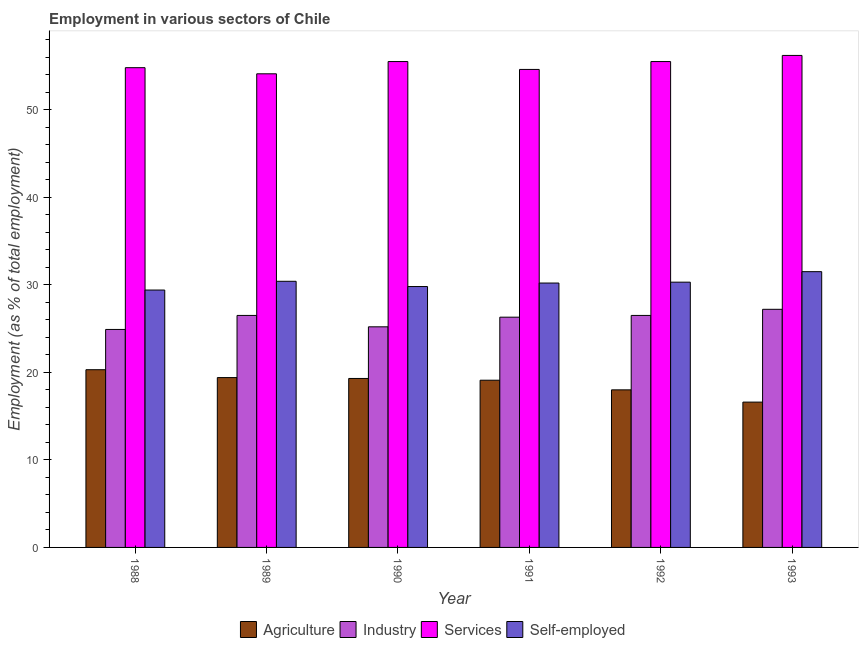How many different coloured bars are there?
Your answer should be very brief. 4. Are the number of bars per tick equal to the number of legend labels?
Your answer should be very brief. Yes. How many bars are there on the 5th tick from the left?
Your answer should be compact. 4. How many bars are there on the 6th tick from the right?
Give a very brief answer. 4. What is the label of the 5th group of bars from the left?
Make the answer very short. 1992. What is the percentage of workers in industry in 1991?
Ensure brevity in your answer.  26.3. Across all years, what is the maximum percentage of workers in industry?
Provide a short and direct response. 27.2. Across all years, what is the minimum percentage of workers in services?
Make the answer very short. 54.1. What is the total percentage of self employed workers in the graph?
Provide a short and direct response. 181.6. What is the difference between the percentage of workers in agriculture in 1989 and that in 1991?
Offer a very short reply. 0.3. What is the difference between the percentage of self employed workers in 1993 and the percentage of workers in industry in 1991?
Your answer should be very brief. 1.3. What is the average percentage of workers in industry per year?
Give a very brief answer. 26.1. What is the ratio of the percentage of self employed workers in 1988 to that in 1993?
Make the answer very short. 0.93. Is the percentage of workers in services in 1990 less than that in 1992?
Make the answer very short. No. Is the difference between the percentage of workers in agriculture in 1988 and 1993 greater than the difference between the percentage of workers in services in 1988 and 1993?
Give a very brief answer. No. What is the difference between the highest and the second highest percentage of workers in agriculture?
Provide a succinct answer. 0.9. What is the difference between the highest and the lowest percentage of workers in agriculture?
Offer a terse response. 3.7. Is it the case that in every year, the sum of the percentage of self employed workers and percentage of workers in services is greater than the sum of percentage of workers in agriculture and percentage of workers in industry?
Your answer should be compact. Yes. What does the 3rd bar from the left in 1993 represents?
Give a very brief answer. Services. What does the 4th bar from the right in 1992 represents?
Keep it short and to the point. Agriculture. Are all the bars in the graph horizontal?
Your answer should be compact. No. How many years are there in the graph?
Provide a succinct answer. 6. Does the graph contain any zero values?
Offer a terse response. No. How many legend labels are there?
Make the answer very short. 4. How are the legend labels stacked?
Offer a terse response. Horizontal. What is the title of the graph?
Offer a terse response. Employment in various sectors of Chile. What is the label or title of the Y-axis?
Your response must be concise. Employment (as % of total employment). What is the Employment (as % of total employment) in Agriculture in 1988?
Offer a terse response. 20.3. What is the Employment (as % of total employment) of Industry in 1988?
Your response must be concise. 24.9. What is the Employment (as % of total employment) of Services in 1988?
Give a very brief answer. 54.8. What is the Employment (as % of total employment) of Self-employed in 1988?
Your answer should be compact. 29.4. What is the Employment (as % of total employment) in Agriculture in 1989?
Keep it short and to the point. 19.4. What is the Employment (as % of total employment) in Services in 1989?
Offer a terse response. 54.1. What is the Employment (as % of total employment) in Self-employed in 1989?
Give a very brief answer. 30.4. What is the Employment (as % of total employment) in Agriculture in 1990?
Your answer should be very brief. 19.3. What is the Employment (as % of total employment) of Industry in 1990?
Provide a short and direct response. 25.2. What is the Employment (as % of total employment) of Services in 1990?
Ensure brevity in your answer.  55.5. What is the Employment (as % of total employment) of Self-employed in 1990?
Your answer should be compact. 29.8. What is the Employment (as % of total employment) of Agriculture in 1991?
Keep it short and to the point. 19.1. What is the Employment (as % of total employment) of Industry in 1991?
Ensure brevity in your answer.  26.3. What is the Employment (as % of total employment) in Services in 1991?
Ensure brevity in your answer.  54.6. What is the Employment (as % of total employment) of Self-employed in 1991?
Offer a very short reply. 30.2. What is the Employment (as % of total employment) in Industry in 1992?
Your response must be concise. 26.5. What is the Employment (as % of total employment) of Services in 1992?
Offer a terse response. 55.5. What is the Employment (as % of total employment) in Self-employed in 1992?
Make the answer very short. 30.3. What is the Employment (as % of total employment) in Agriculture in 1993?
Your response must be concise. 16.6. What is the Employment (as % of total employment) of Industry in 1993?
Offer a terse response. 27.2. What is the Employment (as % of total employment) in Services in 1993?
Make the answer very short. 56.2. What is the Employment (as % of total employment) of Self-employed in 1993?
Keep it short and to the point. 31.5. Across all years, what is the maximum Employment (as % of total employment) of Agriculture?
Ensure brevity in your answer.  20.3. Across all years, what is the maximum Employment (as % of total employment) in Industry?
Ensure brevity in your answer.  27.2. Across all years, what is the maximum Employment (as % of total employment) in Services?
Provide a succinct answer. 56.2. Across all years, what is the maximum Employment (as % of total employment) of Self-employed?
Provide a short and direct response. 31.5. Across all years, what is the minimum Employment (as % of total employment) of Agriculture?
Your answer should be very brief. 16.6. Across all years, what is the minimum Employment (as % of total employment) in Industry?
Ensure brevity in your answer.  24.9. Across all years, what is the minimum Employment (as % of total employment) of Services?
Offer a terse response. 54.1. Across all years, what is the minimum Employment (as % of total employment) in Self-employed?
Provide a short and direct response. 29.4. What is the total Employment (as % of total employment) in Agriculture in the graph?
Your answer should be compact. 112.7. What is the total Employment (as % of total employment) of Industry in the graph?
Ensure brevity in your answer.  156.6. What is the total Employment (as % of total employment) of Services in the graph?
Provide a succinct answer. 330.7. What is the total Employment (as % of total employment) of Self-employed in the graph?
Give a very brief answer. 181.6. What is the difference between the Employment (as % of total employment) in Services in 1988 and that in 1989?
Your answer should be compact. 0.7. What is the difference between the Employment (as % of total employment) in Agriculture in 1988 and that in 1991?
Offer a terse response. 1.2. What is the difference between the Employment (as % of total employment) of Services in 1988 and that in 1991?
Offer a very short reply. 0.2. What is the difference between the Employment (as % of total employment) in Agriculture in 1988 and that in 1992?
Offer a terse response. 2.3. What is the difference between the Employment (as % of total employment) in Industry in 1988 and that in 1992?
Keep it short and to the point. -1.6. What is the difference between the Employment (as % of total employment) of Services in 1988 and that in 1992?
Give a very brief answer. -0.7. What is the difference between the Employment (as % of total employment) in Self-employed in 1988 and that in 1992?
Offer a terse response. -0.9. What is the difference between the Employment (as % of total employment) in Industry in 1988 and that in 1993?
Provide a succinct answer. -2.3. What is the difference between the Employment (as % of total employment) in Self-employed in 1988 and that in 1993?
Ensure brevity in your answer.  -2.1. What is the difference between the Employment (as % of total employment) in Agriculture in 1989 and that in 1990?
Offer a terse response. 0.1. What is the difference between the Employment (as % of total employment) in Services in 1989 and that in 1990?
Provide a short and direct response. -1.4. What is the difference between the Employment (as % of total employment) in Agriculture in 1989 and that in 1991?
Your answer should be very brief. 0.3. What is the difference between the Employment (as % of total employment) of Industry in 1989 and that in 1991?
Your answer should be compact. 0.2. What is the difference between the Employment (as % of total employment) of Services in 1989 and that in 1991?
Make the answer very short. -0.5. What is the difference between the Employment (as % of total employment) in Industry in 1989 and that in 1992?
Provide a succinct answer. 0. What is the difference between the Employment (as % of total employment) of Agriculture in 1989 and that in 1993?
Give a very brief answer. 2.8. What is the difference between the Employment (as % of total employment) of Services in 1989 and that in 1993?
Give a very brief answer. -2.1. What is the difference between the Employment (as % of total employment) of Agriculture in 1990 and that in 1991?
Offer a terse response. 0.2. What is the difference between the Employment (as % of total employment) in Services in 1990 and that in 1991?
Provide a succinct answer. 0.9. What is the difference between the Employment (as % of total employment) of Agriculture in 1990 and that in 1993?
Provide a succinct answer. 2.7. What is the difference between the Employment (as % of total employment) in Industry in 1990 and that in 1993?
Offer a very short reply. -2. What is the difference between the Employment (as % of total employment) in Services in 1990 and that in 1993?
Keep it short and to the point. -0.7. What is the difference between the Employment (as % of total employment) in Self-employed in 1990 and that in 1993?
Offer a terse response. -1.7. What is the difference between the Employment (as % of total employment) in Agriculture in 1991 and that in 1992?
Provide a succinct answer. 1.1. What is the difference between the Employment (as % of total employment) in Self-employed in 1991 and that in 1992?
Your answer should be very brief. -0.1. What is the difference between the Employment (as % of total employment) of Agriculture in 1991 and that in 1993?
Offer a very short reply. 2.5. What is the difference between the Employment (as % of total employment) in Self-employed in 1991 and that in 1993?
Provide a short and direct response. -1.3. What is the difference between the Employment (as % of total employment) in Industry in 1992 and that in 1993?
Offer a very short reply. -0.7. What is the difference between the Employment (as % of total employment) in Services in 1992 and that in 1993?
Make the answer very short. -0.7. What is the difference between the Employment (as % of total employment) of Self-employed in 1992 and that in 1993?
Make the answer very short. -1.2. What is the difference between the Employment (as % of total employment) of Agriculture in 1988 and the Employment (as % of total employment) of Industry in 1989?
Make the answer very short. -6.2. What is the difference between the Employment (as % of total employment) in Agriculture in 1988 and the Employment (as % of total employment) in Services in 1989?
Your answer should be very brief. -33.8. What is the difference between the Employment (as % of total employment) in Industry in 1988 and the Employment (as % of total employment) in Services in 1989?
Your response must be concise. -29.2. What is the difference between the Employment (as % of total employment) in Industry in 1988 and the Employment (as % of total employment) in Self-employed in 1989?
Offer a terse response. -5.5. What is the difference between the Employment (as % of total employment) in Services in 1988 and the Employment (as % of total employment) in Self-employed in 1989?
Give a very brief answer. 24.4. What is the difference between the Employment (as % of total employment) of Agriculture in 1988 and the Employment (as % of total employment) of Industry in 1990?
Make the answer very short. -4.9. What is the difference between the Employment (as % of total employment) of Agriculture in 1988 and the Employment (as % of total employment) of Services in 1990?
Provide a short and direct response. -35.2. What is the difference between the Employment (as % of total employment) of Agriculture in 1988 and the Employment (as % of total employment) of Self-employed in 1990?
Keep it short and to the point. -9.5. What is the difference between the Employment (as % of total employment) in Industry in 1988 and the Employment (as % of total employment) in Services in 1990?
Give a very brief answer. -30.6. What is the difference between the Employment (as % of total employment) in Industry in 1988 and the Employment (as % of total employment) in Self-employed in 1990?
Provide a short and direct response. -4.9. What is the difference between the Employment (as % of total employment) in Services in 1988 and the Employment (as % of total employment) in Self-employed in 1990?
Your answer should be very brief. 25. What is the difference between the Employment (as % of total employment) in Agriculture in 1988 and the Employment (as % of total employment) in Industry in 1991?
Your answer should be very brief. -6. What is the difference between the Employment (as % of total employment) in Agriculture in 1988 and the Employment (as % of total employment) in Services in 1991?
Ensure brevity in your answer.  -34.3. What is the difference between the Employment (as % of total employment) in Industry in 1988 and the Employment (as % of total employment) in Services in 1991?
Ensure brevity in your answer.  -29.7. What is the difference between the Employment (as % of total employment) of Industry in 1988 and the Employment (as % of total employment) of Self-employed in 1991?
Your response must be concise. -5.3. What is the difference between the Employment (as % of total employment) in Services in 1988 and the Employment (as % of total employment) in Self-employed in 1991?
Your response must be concise. 24.6. What is the difference between the Employment (as % of total employment) of Agriculture in 1988 and the Employment (as % of total employment) of Industry in 1992?
Your answer should be compact. -6.2. What is the difference between the Employment (as % of total employment) of Agriculture in 1988 and the Employment (as % of total employment) of Services in 1992?
Your response must be concise. -35.2. What is the difference between the Employment (as % of total employment) in Industry in 1988 and the Employment (as % of total employment) in Services in 1992?
Provide a succinct answer. -30.6. What is the difference between the Employment (as % of total employment) of Industry in 1988 and the Employment (as % of total employment) of Self-employed in 1992?
Give a very brief answer. -5.4. What is the difference between the Employment (as % of total employment) in Services in 1988 and the Employment (as % of total employment) in Self-employed in 1992?
Offer a very short reply. 24.5. What is the difference between the Employment (as % of total employment) in Agriculture in 1988 and the Employment (as % of total employment) in Services in 1993?
Offer a terse response. -35.9. What is the difference between the Employment (as % of total employment) of Agriculture in 1988 and the Employment (as % of total employment) of Self-employed in 1993?
Provide a succinct answer. -11.2. What is the difference between the Employment (as % of total employment) in Industry in 1988 and the Employment (as % of total employment) in Services in 1993?
Offer a very short reply. -31.3. What is the difference between the Employment (as % of total employment) of Services in 1988 and the Employment (as % of total employment) of Self-employed in 1993?
Keep it short and to the point. 23.3. What is the difference between the Employment (as % of total employment) in Agriculture in 1989 and the Employment (as % of total employment) in Industry in 1990?
Keep it short and to the point. -5.8. What is the difference between the Employment (as % of total employment) in Agriculture in 1989 and the Employment (as % of total employment) in Services in 1990?
Ensure brevity in your answer.  -36.1. What is the difference between the Employment (as % of total employment) of Industry in 1989 and the Employment (as % of total employment) of Services in 1990?
Keep it short and to the point. -29. What is the difference between the Employment (as % of total employment) of Services in 1989 and the Employment (as % of total employment) of Self-employed in 1990?
Your response must be concise. 24.3. What is the difference between the Employment (as % of total employment) in Agriculture in 1989 and the Employment (as % of total employment) in Services in 1991?
Offer a very short reply. -35.2. What is the difference between the Employment (as % of total employment) of Agriculture in 1989 and the Employment (as % of total employment) of Self-employed in 1991?
Offer a terse response. -10.8. What is the difference between the Employment (as % of total employment) of Industry in 1989 and the Employment (as % of total employment) of Services in 1991?
Offer a very short reply. -28.1. What is the difference between the Employment (as % of total employment) in Industry in 1989 and the Employment (as % of total employment) in Self-employed in 1991?
Your answer should be very brief. -3.7. What is the difference between the Employment (as % of total employment) of Services in 1989 and the Employment (as % of total employment) of Self-employed in 1991?
Your answer should be very brief. 23.9. What is the difference between the Employment (as % of total employment) of Agriculture in 1989 and the Employment (as % of total employment) of Industry in 1992?
Make the answer very short. -7.1. What is the difference between the Employment (as % of total employment) of Agriculture in 1989 and the Employment (as % of total employment) of Services in 1992?
Provide a succinct answer. -36.1. What is the difference between the Employment (as % of total employment) of Agriculture in 1989 and the Employment (as % of total employment) of Self-employed in 1992?
Provide a succinct answer. -10.9. What is the difference between the Employment (as % of total employment) of Services in 1989 and the Employment (as % of total employment) of Self-employed in 1992?
Offer a very short reply. 23.8. What is the difference between the Employment (as % of total employment) in Agriculture in 1989 and the Employment (as % of total employment) in Industry in 1993?
Offer a very short reply. -7.8. What is the difference between the Employment (as % of total employment) of Agriculture in 1989 and the Employment (as % of total employment) of Services in 1993?
Ensure brevity in your answer.  -36.8. What is the difference between the Employment (as % of total employment) of Industry in 1989 and the Employment (as % of total employment) of Services in 1993?
Your answer should be compact. -29.7. What is the difference between the Employment (as % of total employment) of Services in 1989 and the Employment (as % of total employment) of Self-employed in 1993?
Give a very brief answer. 22.6. What is the difference between the Employment (as % of total employment) of Agriculture in 1990 and the Employment (as % of total employment) of Services in 1991?
Offer a terse response. -35.3. What is the difference between the Employment (as % of total employment) in Industry in 1990 and the Employment (as % of total employment) in Services in 1991?
Ensure brevity in your answer.  -29.4. What is the difference between the Employment (as % of total employment) in Services in 1990 and the Employment (as % of total employment) in Self-employed in 1991?
Your answer should be very brief. 25.3. What is the difference between the Employment (as % of total employment) in Agriculture in 1990 and the Employment (as % of total employment) in Industry in 1992?
Keep it short and to the point. -7.2. What is the difference between the Employment (as % of total employment) in Agriculture in 1990 and the Employment (as % of total employment) in Services in 1992?
Provide a short and direct response. -36.2. What is the difference between the Employment (as % of total employment) in Industry in 1990 and the Employment (as % of total employment) in Services in 1992?
Offer a terse response. -30.3. What is the difference between the Employment (as % of total employment) in Industry in 1990 and the Employment (as % of total employment) in Self-employed in 1992?
Ensure brevity in your answer.  -5.1. What is the difference between the Employment (as % of total employment) of Services in 1990 and the Employment (as % of total employment) of Self-employed in 1992?
Ensure brevity in your answer.  25.2. What is the difference between the Employment (as % of total employment) in Agriculture in 1990 and the Employment (as % of total employment) in Services in 1993?
Your response must be concise. -36.9. What is the difference between the Employment (as % of total employment) in Agriculture in 1990 and the Employment (as % of total employment) in Self-employed in 1993?
Your answer should be very brief. -12.2. What is the difference between the Employment (as % of total employment) of Industry in 1990 and the Employment (as % of total employment) of Services in 1993?
Your answer should be very brief. -31. What is the difference between the Employment (as % of total employment) of Agriculture in 1991 and the Employment (as % of total employment) of Services in 1992?
Provide a short and direct response. -36.4. What is the difference between the Employment (as % of total employment) of Industry in 1991 and the Employment (as % of total employment) of Services in 1992?
Provide a succinct answer. -29.2. What is the difference between the Employment (as % of total employment) of Services in 1991 and the Employment (as % of total employment) of Self-employed in 1992?
Your answer should be very brief. 24.3. What is the difference between the Employment (as % of total employment) of Agriculture in 1991 and the Employment (as % of total employment) of Services in 1993?
Provide a short and direct response. -37.1. What is the difference between the Employment (as % of total employment) of Industry in 1991 and the Employment (as % of total employment) of Services in 1993?
Offer a terse response. -29.9. What is the difference between the Employment (as % of total employment) in Services in 1991 and the Employment (as % of total employment) in Self-employed in 1993?
Your response must be concise. 23.1. What is the difference between the Employment (as % of total employment) in Agriculture in 1992 and the Employment (as % of total employment) in Services in 1993?
Offer a very short reply. -38.2. What is the difference between the Employment (as % of total employment) in Agriculture in 1992 and the Employment (as % of total employment) in Self-employed in 1993?
Your answer should be compact. -13.5. What is the difference between the Employment (as % of total employment) in Industry in 1992 and the Employment (as % of total employment) in Services in 1993?
Provide a succinct answer. -29.7. What is the difference between the Employment (as % of total employment) in Industry in 1992 and the Employment (as % of total employment) in Self-employed in 1993?
Make the answer very short. -5. What is the average Employment (as % of total employment) of Agriculture per year?
Your answer should be compact. 18.78. What is the average Employment (as % of total employment) of Industry per year?
Provide a short and direct response. 26.1. What is the average Employment (as % of total employment) in Services per year?
Make the answer very short. 55.12. What is the average Employment (as % of total employment) in Self-employed per year?
Offer a very short reply. 30.27. In the year 1988, what is the difference between the Employment (as % of total employment) in Agriculture and Employment (as % of total employment) in Services?
Give a very brief answer. -34.5. In the year 1988, what is the difference between the Employment (as % of total employment) of Industry and Employment (as % of total employment) of Services?
Ensure brevity in your answer.  -29.9. In the year 1988, what is the difference between the Employment (as % of total employment) in Services and Employment (as % of total employment) in Self-employed?
Provide a succinct answer. 25.4. In the year 1989, what is the difference between the Employment (as % of total employment) in Agriculture and Employment (as % of total employment) in Industry?
Offer a very short reply. -7.1. In the year 1989, what is the difference between the Employment (as % of total employment) in Agriculture and Employment (as % of total employment) in Services?
Ensure brevity in your answer.  -34.7. In the year 1989, what is the difference between the Employment (as % of total employment) of Industry and Employment (as % of total employment) of Services?
Give a very brief answer. -27.6. In the year 1989, what is the difference between the Employment (as % of total employment) in Industry and Employment (as % of total employment) in Self-employed?
Ensure brevity in your answer.  -3.9. In the year 1989, what is the difference between the Employment (as % of total employment) in Services and Employment (as % of total employment) in Self-employed?
Provide a short and direct response. 23.7. In the year 1990, what is the difference between the Employment (as % of total employment) of Agriculture and Employment (as % of total employment) of Services?
Give a very brief answer. -36.2. In the year 1990, what is the difference between the Employment (as % of total employment) in Industry and Employment (as % of total employment) in Services?
Offer a terse response. -30.3. In the year 1990, what is the difference between the Employment (as % of total employment) in Services and Employment (as % of total employment) in Self-employed?
Make the answer very short. 25.7. In the year 1991, what is the difference between the Employment (as % of total employment) of Agriculture and Employment (as % of total employment) of Services?
Give a very brief answer. -35.5. In the year 1991, what is the difference between the Employment (as % of total employment) in Agriculture and Employment (as % of total employment) in Self-employed?
Your answer should be very brief. -11.1. In the year 1991, what is the difference between the Employment (as % of total employment) of Industry and Employment (as % of total employment) of Services?
Make the answer very short. -28.3. In the year 1991, what is the difference between the Employment (as % of total employment) of Industry and Employment (as % of total employment) of Self-employed?
Make the answer very short. -3.9. In the year 1991, what is the difference between the Employment (as % of total employment) of Services and Employment (as % of total employment) of Self-employed?
Your answer should be very brief. 24.4. In the year 1992, what is the difference between the Employment (as % of total employment) in Agriculture and Employment (as % of total employment) in Services?
Provide a short and direct response. -37.5. In the year 1992, what is the difference between the Employment (as % of total employment) of Industry and Employment (as % of total employment) of Self-employed?
Keep it short and to the point. -3.8. In the year 1992, what is the difference between the Employment (as % of total employment) of Services and Employment (as % of total employment) of Self-employed?
Your response must be concise. 25.2. In the year 1993, what is the difference between the Employment (as % of total employment) in Agriculture and Employment (as % of total employment) in Industry?
Offer a terse response. -10.6. In the year 1993, what is the difference between the Employment (as % of total employment) of Agriculture and Employment (as % of total employment) of Services?
Ensure brevity in your answer.  -39.6. In the year 1993, what is the difference between the Employment (as % of total employment) in Agriculture and Employment (as % of total employment) in Self-employed?
Keep it short and to the point. -14.9. In the year 1993, what is the difference between the Employment (as % of total employment) of Industry and Employment (as % of total employment) of Services?
Make the answer very short. -29. In the year 1993, what is the difference between the Employment (as % of total employment) of Services and Employment (as % of total employment) of Self-employed?
Give a very brief answer. 24.7. What is the ratio of the Employment (as % of total employment) in Agriculture in 1988 to that in 1989?
Provide a succinct answer. 1.05. What is the ratio of the Employment (as % of total employment) of Industry in 1988 to that in 1989?
Give a very brief answer. 0.94. What is the ratio of the Employment (as % of total employment) of Services in 1988 to that in 1989?
Your answer should be compact. 1.01. What is the ratio of the Employment (as % of total employment) of Self-employed in 1988 to that in 1989?
Ensure brevity in your answer.  0.97. What is the ratio of the Employment (as % of total employment) in Agriculture in 1988 to that in 1990?
Your answer should be compact. 1.05. What is the ratio of the Employment (as % of total employment) in Industry in 1988 to that in 1990?
Offer a terse response. 0.99. What is the ratio of the Employment (as % of total employment) of Services in 1988 to that in 1990?
Your answer should be very brief. 0.99. What is the ratio of the Employment (as % of total employment) of Self-employed in 1988 to that in 1990?
Offer a terse response. 0.99. What is the ratio of the Employment (as % of total employment) of Agriculture in 1988 to that in 1991?
Offer a very short reply. 1.06. What is the ratio of the Employment (as % of total employment) in Industry in 1988 to that in 1991?
Your response must be concise. 0.95. What is the ratio of the Employment (as % of total employment) of Self-employed in 1988 to that in 1991?
Your answer should be very brief. 0.97. What is the ratio of the Employment (as % of total employment) of Agriculture in 1988 to that in 1992?
Offer a very short reply. 1.13. What is the ratio of the Employment (as % of total employment) in Industry in 1988 to that in 1992?
Your response must be concise. 0.94. What is the ratio of the Employment (as % of total employment) of Services in 1988 to that in 1992?
Your answer should be compact. 0.99. What is the ratio of the Employment (as % of total employment) in Self-employed in 1988 to that in 1992?
Keep it short and to the point. 0.97. What is the ratio of the Employment (as % of total employment) in Agriculture in 1988 to that in 1993?
Your answer should be very brief. 1.22. What is the ratio of the Employment (as % of total employment) in Industry in 1988 to that in 1993?
Provide a short and direct response. 0.92. What is the ratio of the Employment (as % of total employment) in Services in 1988 to that in 1993?
Ensure brevity in your answer.  0.98. What is the ratio of the Employment (as % of total employment) of Self-employed in 1988 to that in 1993?
Offer a very short reply. 0.93. What is the ratio of the Employment (as % of total employment) of Industry in 1989 to that in 1990?
Offer a very short reply. 1.05. What is the ratio of the Employment (as % of total employment) in Services in 1989 to that in 1990?
Provide a short and direct response. 0.97. What is the ratio of the Employment (as % of total employment) in Self-employed in 1989 to that in 1990?
Ensure brevity in your answer.  1.02. What is the ratio of the Employment (as % of total employment) in Agriculture in 1989 to that in 1991?
Provide a short and direct response. 1.02. What is the ratio of the Employment (as % of total employment) of Industry in 1989 to that in 1991?
Provide a short and direct response. 1.01. What is the ratio of the Employment (as % of total employment) in Self-employed in 1989 to that in 1991?
Offer a very short reply. 1.01. What is the ratio of the Employment (as % of total employment) in Agriculture in 1989 to that in 1992?
Ensure brevity in your answer.  1.08. What is the ratio of the Employment (as % of total employment) of Services in 1989 to that in 1992?
Your response must be concise. 0.97. What is the ratio of the Employment (as % of total employment) of Self-employed in 1989 to that in 1992?
Provide a succinct answer. 1. What is the ratio of the Employment (as % of total employment) in Agriculture in 1989 to that in 1993?
Your response must be concise. 1.17. What is the ratio of the Employment (as % of total employment) of Industry in 1989 to that in 1993?
Your answer should be compact. 0.97. What is the ratio of the Employment (as % of total employment) in Services in 1989 to that in 1993?
Provide a succinct answer. 0.96. What is the ratio of the Employment (as % of total employment) in Self-employed in 1989 to that in 1993?
Provide a short and direct response. 0.97. What is the ratio of the Employment (as % of total employment) of Agriculture in 1990 to that in 1991?
Offer a terse response. 1.01. What is the ratio of the Employment (as % of total employment) of Industry in 1990 to that in 1991?
Provide a short and direct response. 0.96. What is the ratio of the Employment (as % of total employment) in Services in 1990 to that in 1991?
Give a very brief answer. 1.02. What is the ratio of the Employment (as % of total employment) of Agriculture in 1990 to that in 1992?
Your answer should be compact. 1.07. What is the ratio of the Employment (as % of total employment) in Industry in 1990 to that in 1992?
Your answer should be compact. 0.95. What is the ratio of the Employment (as % of total employment) in Self-employed in 1990 to that in 1992?
Your response must be concise. 0.98. What is the ratio of the Employment (as % of total employment) in Agriculture in 1990 to that in 1993?
Ensure brevity in your answer.  1.16. What is the ratio of the Employment (as % of total employment) in Industry in 1990 to that in 1993?
Keep it short and to the point. 0.93. What is the ratio of the Employment (as % of total employment) of Services in 1990 to that in 1993?
Keep it short and to the point. 0.99. What is the ratio of the Employment (as % of total employment) of Self-employed in 1990 to that in 1993?
Your response must be concise. 0.95. What is the ratio of the Employment (as % of total employment) of Agriculture in 1991 to that in 1992?
Offer a terse response. 1.06. What is the ratio of the Employment (as % of total employment) in Services in 1991 to that in 1992?
Your answer should be compact. 0.98. What is the ratio of the Employment (as % of total employment) in Agriculture in 1991 to that in 1993?
Your response must be concise. 1.15. What is the ratio of the Employment (as % of total employment) in Industry in 1991 to that in 1993?
Provide a short and direct response. 0.97. What is the ratio of the Employment (as % of total employment) in Services in 1991 to that in 1993?
Provide a short and direct response. 0.97. What is the ratio of the Employment (as % of total employment) of Self-employed in 1991 to that in 1993?
Your answer should be very brief. 0.96. What is the ratio of the Employment (as % of total employment) of Agriculture in 1992 to that in 1993?
Give a very brief answer. 1.08. What is the ratio of the Employment (as % of total employment) in Industry in 1992 to that in 1993?
Provide a short and direct response. 0.97. What is the ratio of the Employment (as % of total employment) in Services in 1992 to that in 1993?
Provide a succinct answer. 0.99. What is the ratio of the Employment (as % of total employment) in Self-employed in 1992 to that in 1993?
Keep it short and to the point. 0.96. What is the difference between the highest and the second highest Employment (as % of total employment) of Agriculture?
Your answer should be compact. 0.9. What is the difference between the highest and the second highest Employment (as % of total employment) of Industry?
Your answer should be compact. 0.7. What is the difference between the highest and the second highest Employment (as % of total employment) in Services?
Provide a succinct answer. 0.7. What is the difference between the highest and the second highest Employment (as % of total employment) of Self-employed?
Give a very brief answer. 1.1. What is the difference between the highest and the lowest Employment (as % of total employment) of Industry?
Offer a very short reply. 2.3. What is the difference between the highest and the lowest Employment (as % of total employment) in Services?
Offer a very short reply. 2.1. 